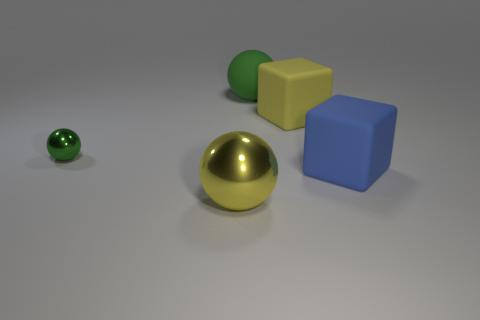There is a sphere that is both behind the big yellow ball and in front of the green rubber thing; what is its color?
Your answer should be very brief. Green. Is the number of big balls that are right of the large green rubber ball less than the number of yellow blocks behind the large blue thing?
Keep it short and to the point. Yes. How many small purple metallic things are the same shape as the green metal thing?
Offer a very short reply. 0. There is a yellow block that is made of the same material as the blue cube; what size is it?
Offer a very short reply. Large. The metallic ball on the left side of the yellow thing that is left of the yellow rubber thing is what color?
Offer a terse response. Green. There is a small green object; does it have the same shape as the yellow object behind the large blue cube?
Offer a very short reply. No. How many other green matte balls are the same size as the green rubber sphere?
Ensure brevity in your answer.  0. There is another green thing that is the same shape as the big green matte object; what is its material?
Your answer should be compact. Metal. Is the color of the big thing that is in front of the blue object the same as the cube to the right of the yellow cube?
Offer a very short reply. No. What is the shape of the yellow thing behind the tiny green object?
Provide a succinct answer. Cube. 